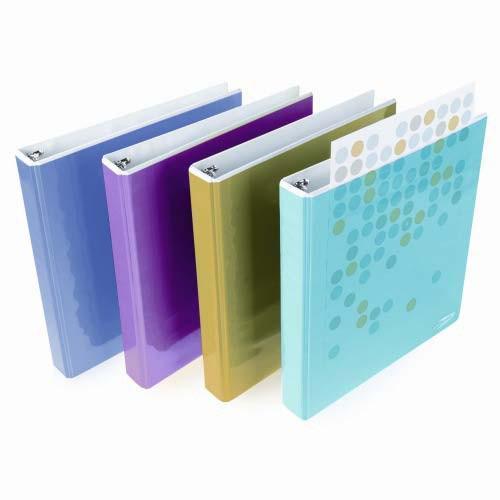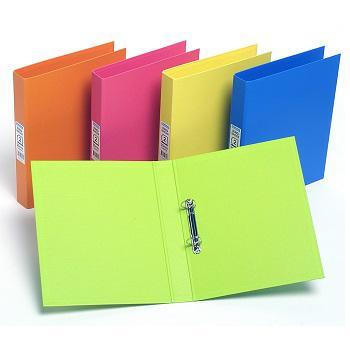The first image is the image on the left, the second image is the image on the right. Evaluate the accuracy of this statement regarding the images: "There are nine binders, all appearing to be different colors.". Is it true? Answer yes or no. Yes. 